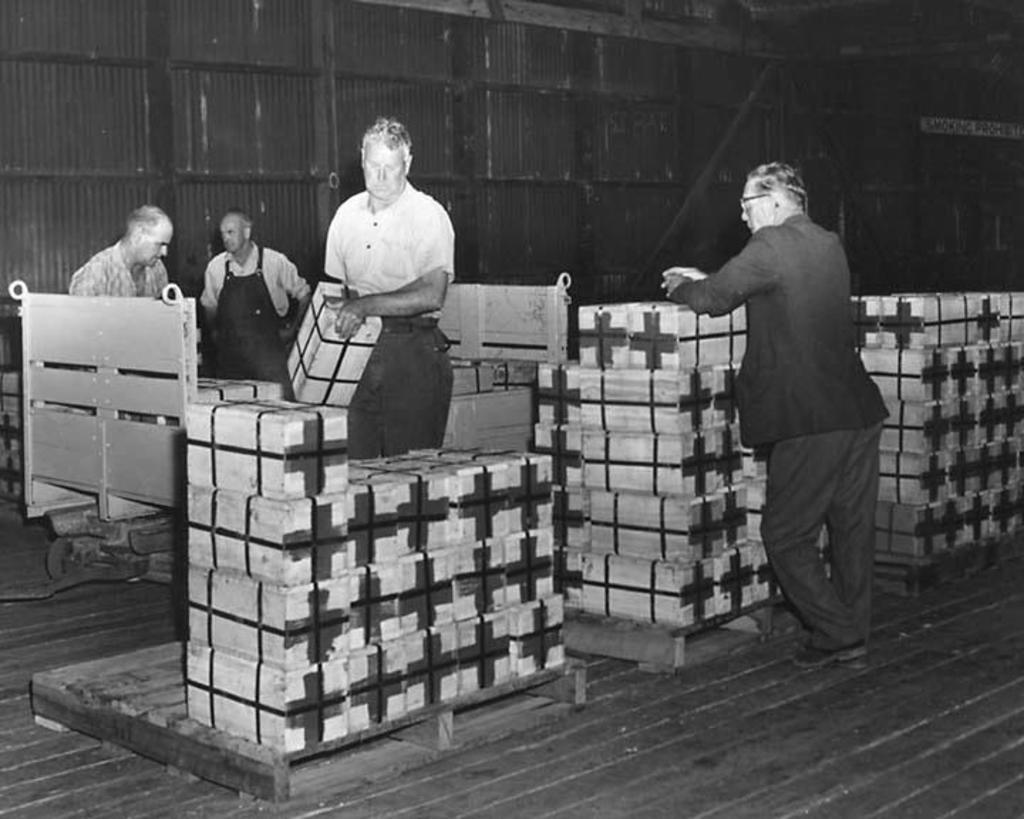How many people are in the shed in the image? There are four persons visible in the shed. What can be seen on the floor of the shed? There are wooden objects on the floor. What is visible at the top of the image? There is a fence visible at the top of the image. What type of creature is sitting on the wooden objects in the shed? There is no creature visible in the shed. 